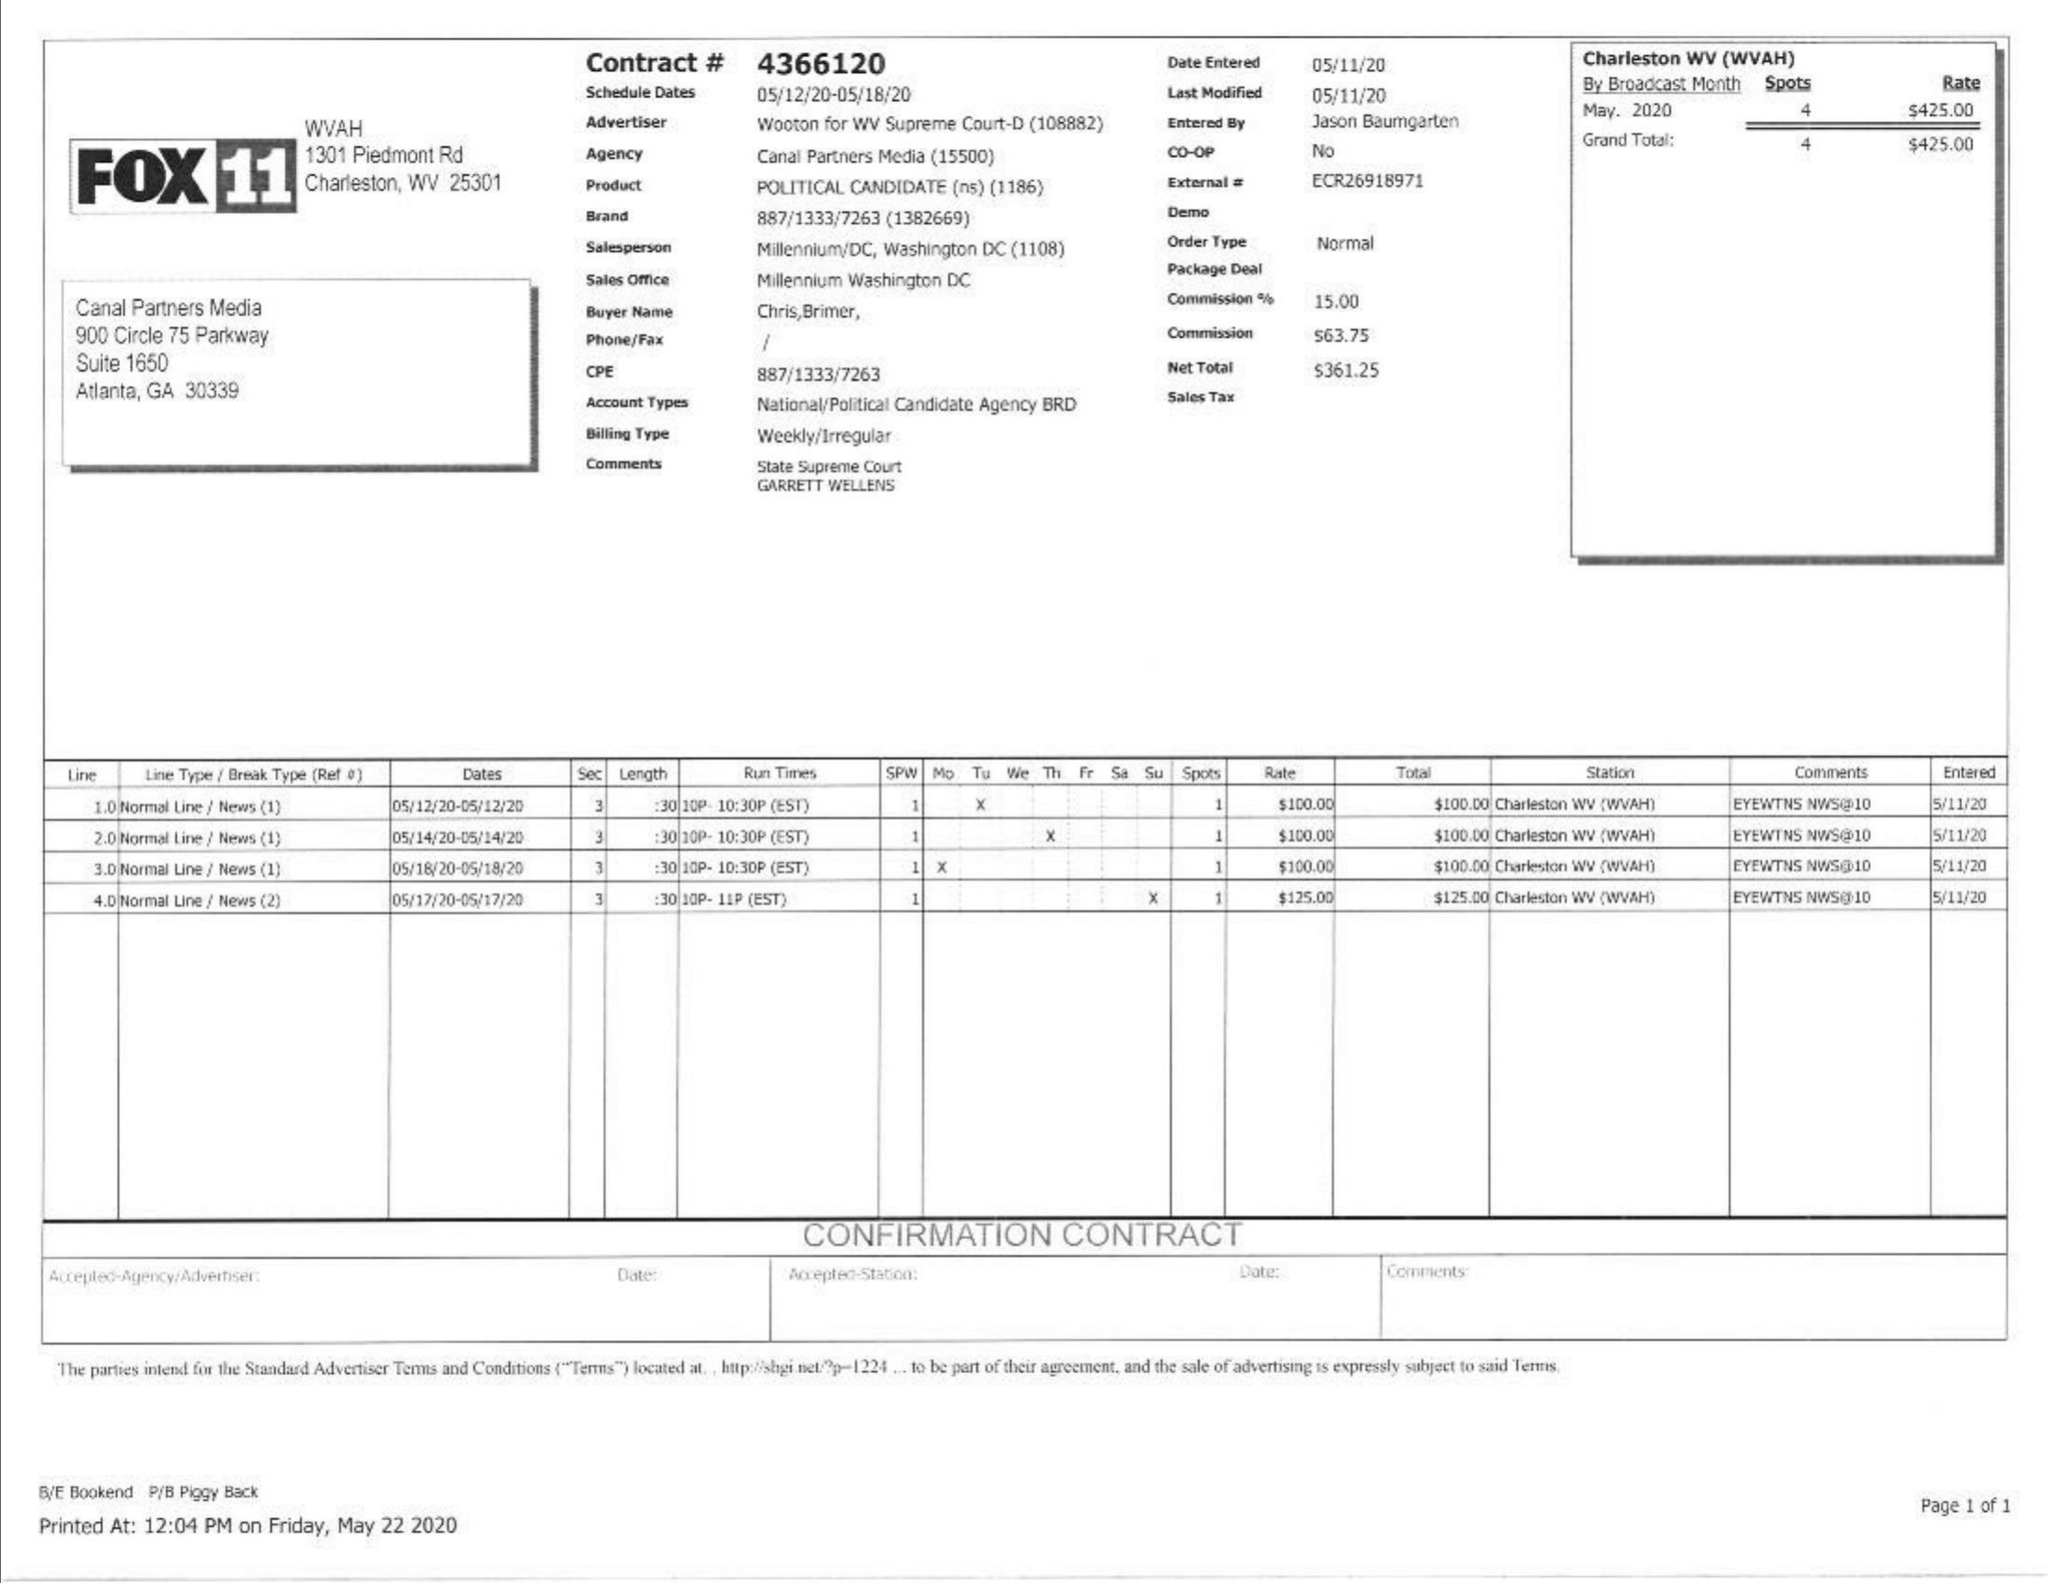What is the value for the advertiser?
Answer the question using a single word or phrase. WOOTON FOR WV SUPREME COURT-D 